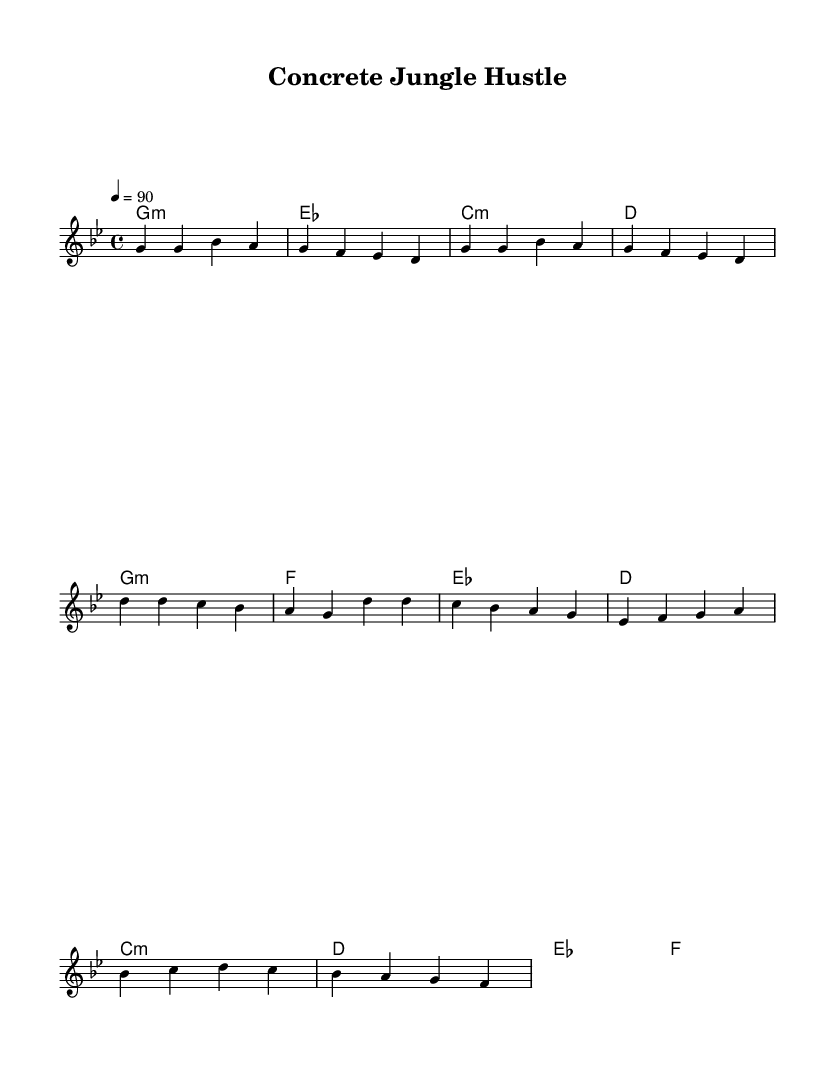What is the key signature of this music? The key signature is indicated by the presence of a flat eighth note, which denotes G minor, having five flats in its scale.
Answer: G minor What is the time signature of this sheet music? The time signature is represented in the beginning of the score with the "4/4" notation, indicating the piece has four beats in a measure.
Answer: 4/4 What is the tempo marking for this piece? The tempo marking is found at the beginning, specifying the piece to be played at a rate of 90 beats per minute, described using "4 = 90".
Answer: 90 How many lines are in the verse lyrics? By examining the lyrics section, I can see there are two lines of lyrics provided in the verse, each line corresponding to a particular melodic passage.
Answer: 2 What type of chord is used in the chorus? The chord progression in the chorus includes G minor and F major, with G minor being the tonal center, as indicated at the beginning of the chorus section.
Answer: G minor How is the hustle theme represented in the lyrics? The hustle theme is encapsulated in the lyrics, primarily through phrases such as "We're hustlin', hustlin' in the concrete jungle", which emphasizes the hard work in the construction environment.
Answer: Concrete jungle 